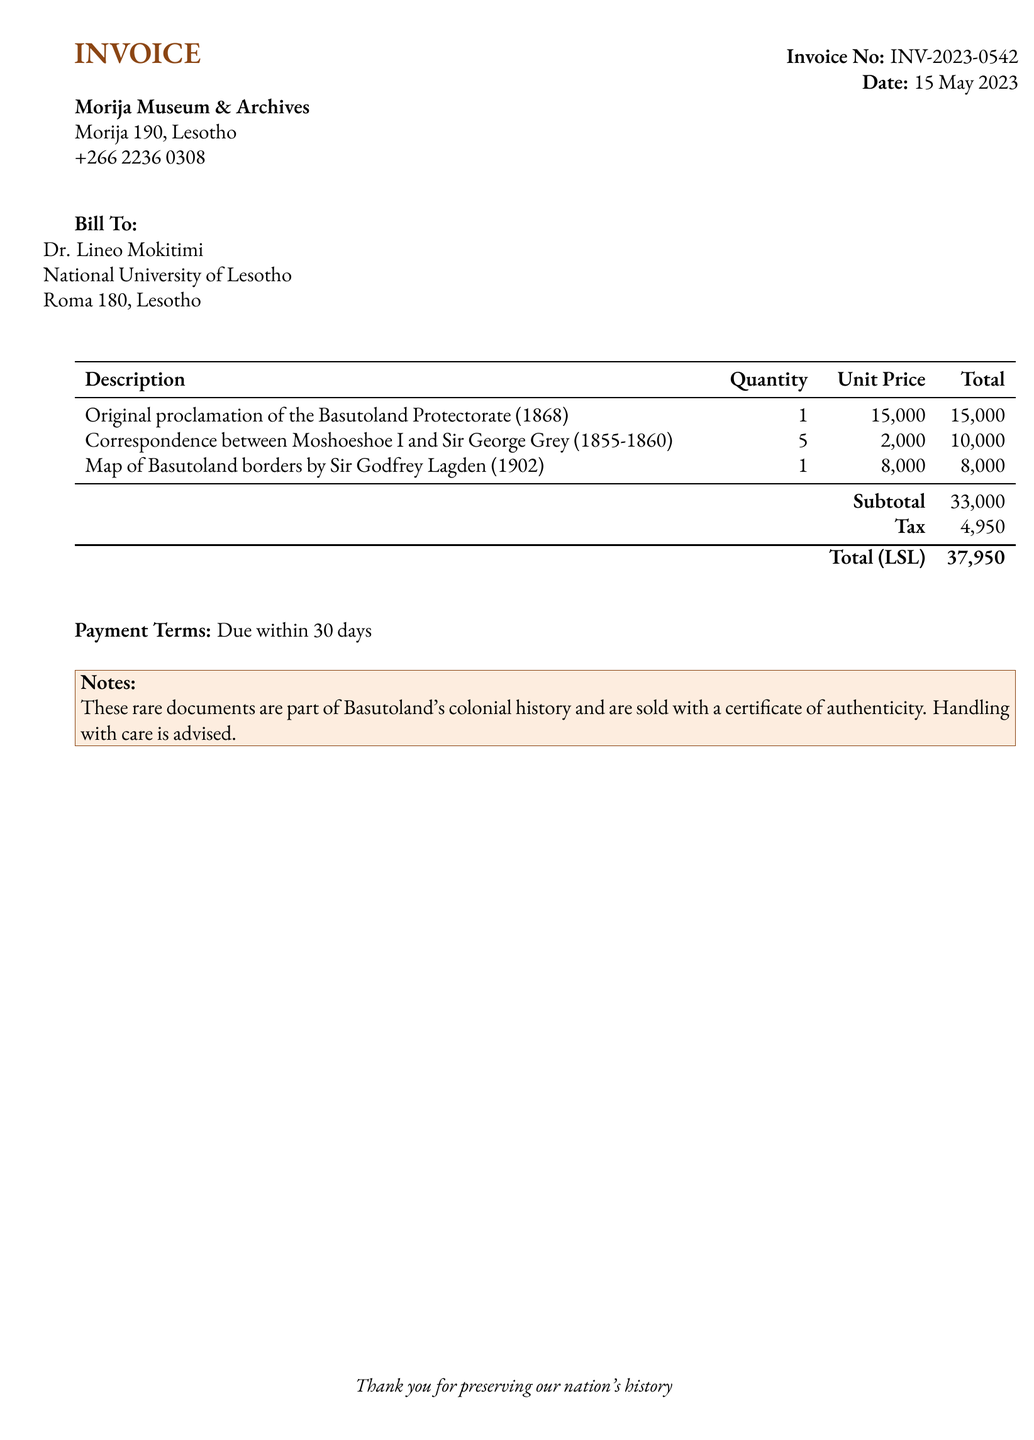what is the invoice number? The invoice number is clearly stated in the document, which is used for tracking the bill.
Answer: INV-2023-0542 what is the total amount due? The total amount due is calculated by adding the subtotal and tax listed in the document.
Answer: 37,950 who is the bill addressed to? The document specifies the recipient of the bill in the 'Bill To' section, indicating who should be held accountable for payment.
Answer: Dr. Lineo Mokitimi how many correspondence documents are included in the purchase? The quantity of the correspondence between Moshoeshoe I and Sir George Grey is listed in the itemized table of the document.
Answer: 5 what is the payment term stated? The payment terms in the document specify when the payment should be made, indicating the due date.
Answer: Due within 30 days when was the invoice issued? The date of issuance is provided near the top of the document, indicating when the transaction was recorded.
Answer: 15 May 2023 what is the tax amount? The tax amount is indicated in the itemized table, which contributes to the total due of the invoice.
Answer: 4,950 what type of documents are being sold? The description of the items in the invoice provides a clear indication of the historical significance of the materials being purchased.
Answer: Rare political documents which historical figure is mentioned in the correspondence? The correspondence listed in the invoice highlights a significant leader from the colonial era, relevant to the history of Basutoland.
Answer: Moshoeshoe I 